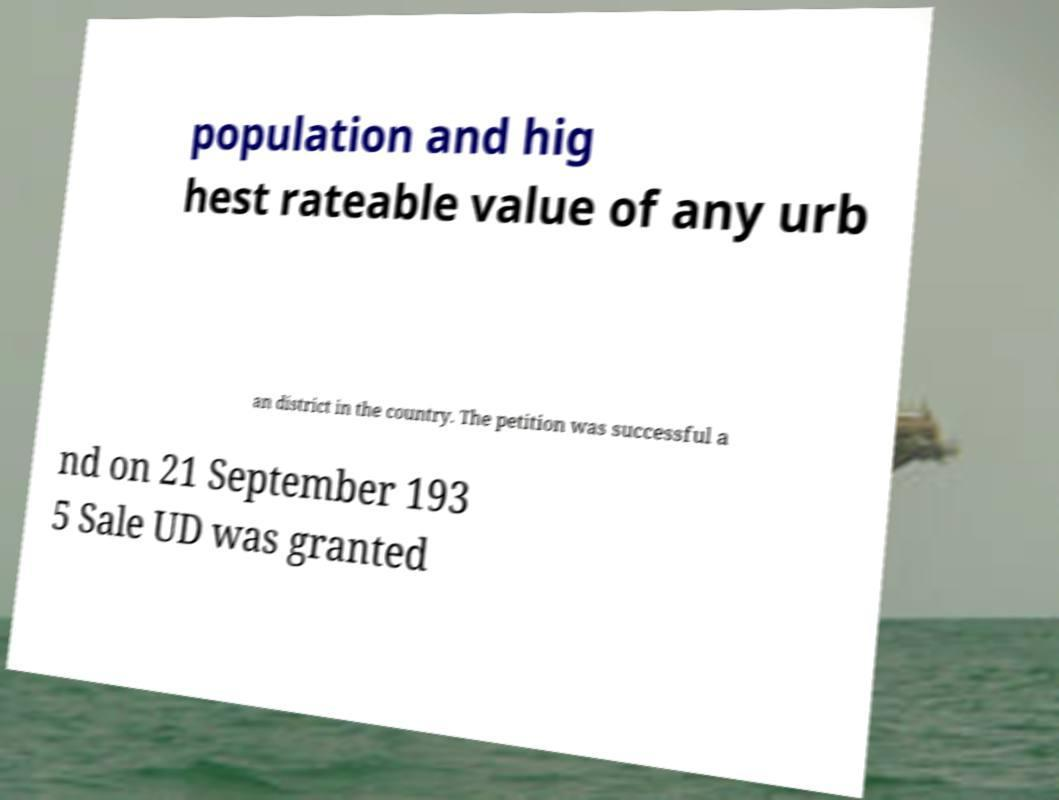Please identify and transcribe the text found in this image. population and hig hest rateable value of any urb an district in the country. The petition was successful a nd on 21 September 193 5 Sale UD was granted 